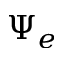Convert formula to latex. <formula><loc_0><loc_0><loc_500><loc_500>\Psi _ { e }</formula> 